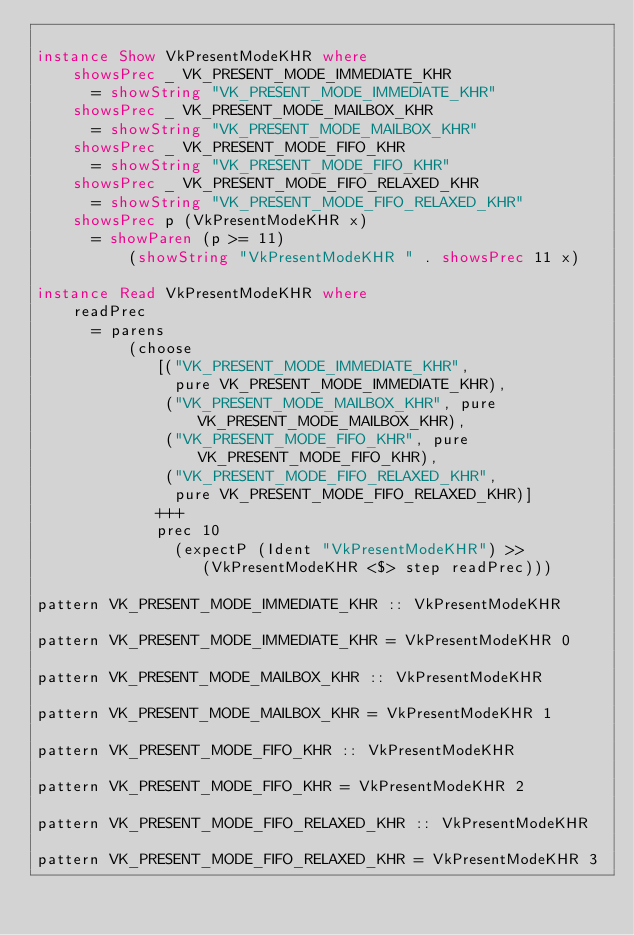Convert code to text. <code><loc_0><loc_0><loc_500><loc_500><_Haskell_>
instance Show VkPresentModeKHR where
    showsPrec _ VK_PRESENT_MODE_IMMEDIATE_KHR
      = showString "VK_PRESENT_MODE_IMMEDIATE_KHR"
    showsPrec _ VK_PRESENT_MODE_MAILBOX_KHR
      = showString "VK_PRESENT_MODE_MAILBOX_KHR"
    showsPrec _ VK_PRESENT_MODE_FIFO_KHR
      = showString "VK_PRESENT_MODE_FIFO_KHR"
    showsPrec _ VK_PRESENT_MODE_FIFO_RELAXED_KHR
      = showString "VK_PRESENT_MODE_FIFO_RELAXED_KHR"
    showsPrec p (VkPresentModeKHR x)
      = showParen (p >= 11)
          (showString "VkPresentModeKHR " . showsPrec 11 x)

instance Read VkPresentModeKHR where
    readPrec
      = parens
          (choose
             [("VK_PRESENT_MODE_IMMEDIATE_KHR",
               pure VK_PRESENT_MODE_IMMEDIATE_KHR),
              ("VK_PRESENT_MODE_MAILBOX_KHR", pure VK_PRESENT_MODE_MAILBOX_KHR),
              ("VK_PRESENT_MODE_FIFO_KHR", pure VK_PRESENT_MODE_FIFO_KHR),
              ("VK_PRESENT_MODE_FIFO_RELAXED_KHR",
               pure VK_PRESENT_MODE_FIFO_RELAXED_KHR)]
             +++
             prec 10
               (expectP (Ident "VkPresentModeKHR") >>
                  (VkPresentModeKHR <$> step readPrec)))

pattern VK_PRESENT_MODE_IMMEDIATE_KHR :: VkPresentModeKHR

pattern VK_PRESENT_MODE_IMMEDIATE_KHR = VkPresentModeKHR 0

pattern VK_PRESENT_MODE_MAILBOX_KHR :: VkPresentModeKHR

pattern VK_PRESENT_MODE_MAILBOX_KHR = VkPresentModeKHR 1

pattern VK_PRESENT_MODE_FIFO_KHR :: VkPresentModeKHR

pattern VK_PRESENT_MODE_FIFO_KHR = VkPresentModeKHR 2

pattern VK_PRESENT_MODE_FIFO_RELAXED_KHR :: VkPresentModeKHR

pattern VK_PRESENT_MODE_FIFO_RELAXED_KHR = VkPresentModeKHR 3
</code> 